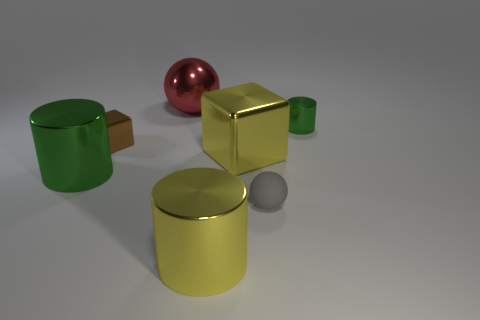Add 1 large cyan things. How many objects exist? 8 Subtract all spheres. How many objects are left? 5 Subtract 0 purple cylinders. How many objects are left? 7 Subtract all small brown metallic objects. Subtract all big gray rubber spheres. How many objects are left? 6 Add 2 big cylinders. How many big cylinders are left? 4 Add 1 matte things. How many matte things exist? 2 